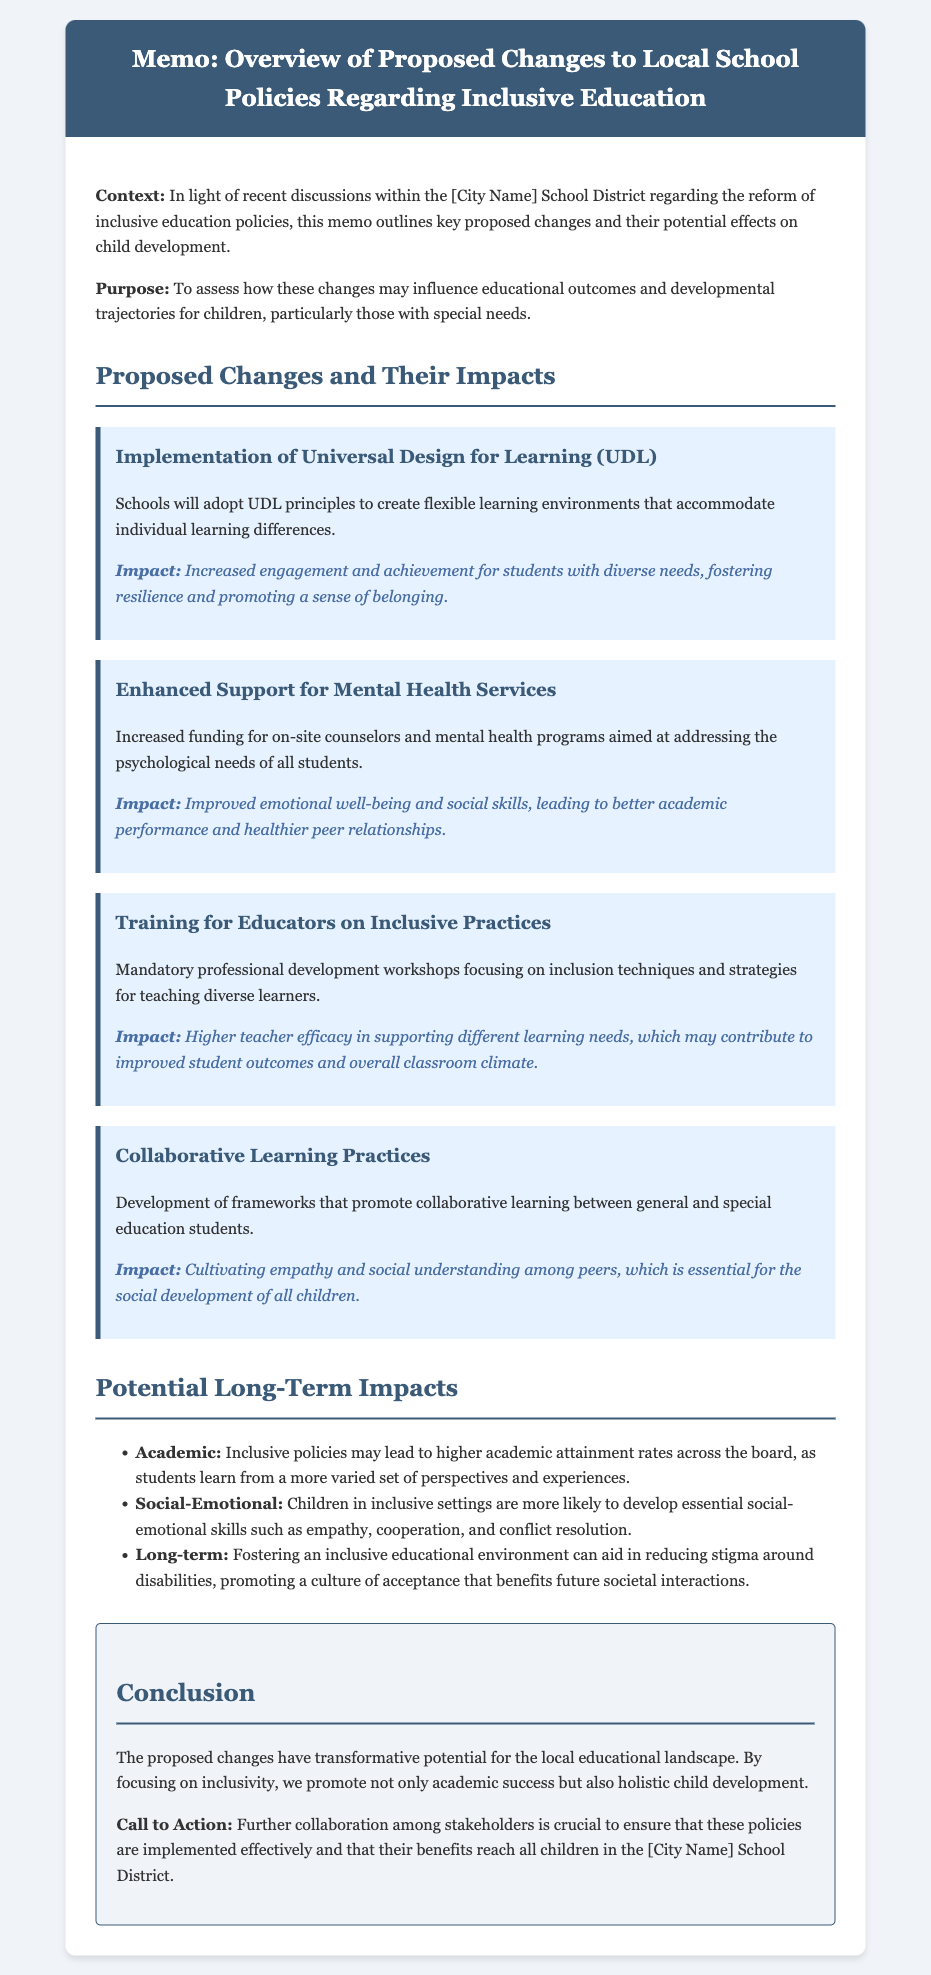What is the title of the memo? The title is explicitly stated at the top of the document.
Answer: Memo: Overview of Proposed Changes to Local School Policies Regarding Inclusive Education What principle will schools implement according to the memo? The text identifies a specific educational principle that schools will adopt.
Answer: Universal Design for Learning (UDL) What type of support will be enhanced in the proposed changes? The memo highlights a specific area of support that will receive increased funding.
Answer: Mental Health Services What training will educators undergo? The document describes a mandatory program for teachers within the proposed changes.
Answer: Training for Educators on Inclusive Practices What social skill is expected to improve through collaborative learning? The memo outlines a social skill that will be developed through collaborative practices.
Answer: Empathy What is one expected long-term academic impact of inclusive policies? The document provides insight into the academic outcomes associated with inclusive education policies.
Answer: Higher academic attainment rates What is a key focus of the proposed changes according to the conclusion? The conclusion emphasizes a specific aim of the policy reforms.
Answer: Inclusivity What is the call to action mentioned in the conclusion? The conclusion includes a specific action recommended for stakeholders.
Answer: Further collaboration among stakeholders is crucial 